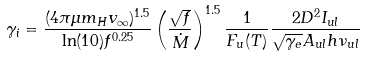<formula> <loc_0><loc_0><loc_500><loc_500>\gamma _ { i } = \frac { ( 4 \pi \mu m _ { H } v _ { \infty } ) ^ { 1 . 5 } } { \ln ( 1 0 ) f ^ { 0 . 2 5 } } \left ( \frac { \sqrt { f } } { \dot { M } } \right ) ^ { 1 . 5 } \frac { 1 } { F _ { u } ( T ) } \frac { 2 D ^ { 2 } I _ { u l } } { \sqrt { \gamma _ { e } } A _ { u l } h \nu _ { u l } }</formula> 